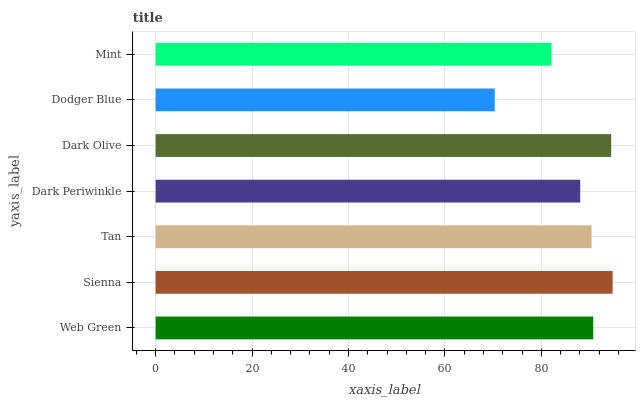Is Dodger Blue the minimum?
Answer yes or no. Yes. Is Sienna the maximum?
Answer yes or no. Yes. Is Tan the minimum?
Answer yes or no. No. Is Tan the maximum?
Answer yes or no. No. Is Sienna greater than Tan?
Answer yes or no. Yes. Is Tan less than Sienna?
Answer yes or no. Yes. Is Tan greater than Sienna?
Answer yes or no. No. Is Sienna less than Tan?
Answer yes or no. No. Is Tan the high median?
Answer yes or no. Yes. Is Tan the low median?
Answer yes or no. Yes. Is Dodger Blue the high median?
Answer yes or no. No. Is Dark Olive the low median?
Answer yes or no. No. 